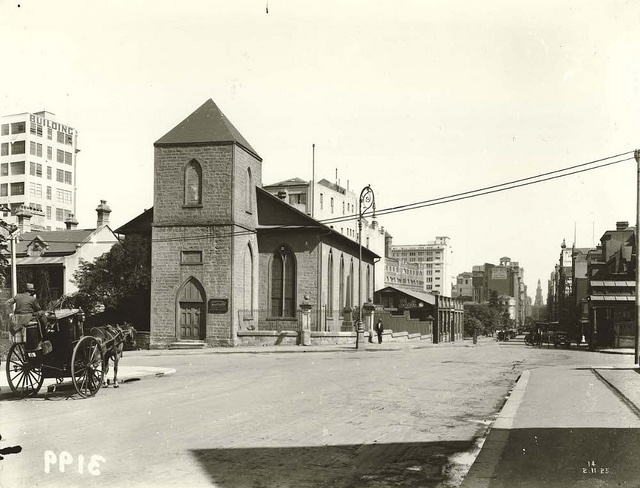Describe the objects in this image and their specific colors. I can see horse in beige, black, gray, ivory, and darkgray tones, people in beige, gray, black, and darkgray tones, people in beige, black, gray, and darkgray tones, horse in beige, black, gray, and darkgray tones, and horse in beige, black, gray, and darkgray tones in this image. 